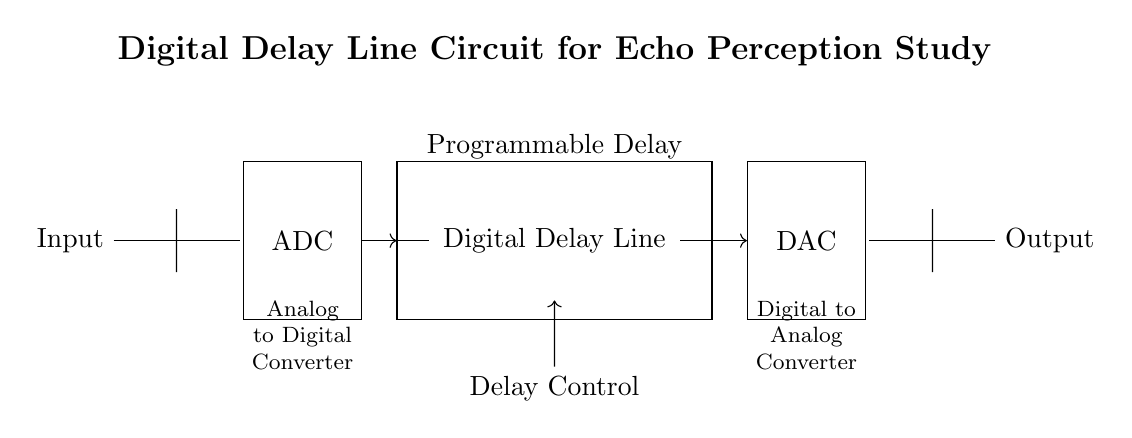What is the first component in the circuit? The first component in the circuit is the Input, which can be seen on the left side. It represents the starting point for signal processing in the circuit.
Answer: Input What is the function of the ADC in this circuit? The ADC (Analog to Digital Converter) converts the incoming analog signal into a digital format, allowing it to be processed by the digital components of the circuit. This is crucial for any digital processing that follows.
Answer: Converts signal What type of circuit is this? This circuit is a Digital Delay Line Circuit, designed for echo perception studies, as indicated in the title of the diagram. It processes audio signals digitally with echo effects.
Answer: Digital Delay Line How many main processing components are in the circuit? The circuit features three main processing components: the ADC, Digital Delay Line, and DAC. These components work together to convert, delay, and convert again the signals as required for the study.
Answer: Three Describe the role of the Delay Control in this circuit. The Delay Control allows the user to program how long the signal delay should be within the Digital Delay Line. This flexibility is necessary to study how different delay times affect echo perception and spatial hearing performance.
Answer: Programmable delay What does DAC stand for in this circuit? DAC stands for Digital to Analog Converter, which converts the processed digital signal back into an analog signal for output. This component is essential for sending the final audio signal to speakers or other analog devices.
Answer: Digital to Analog Converter What is the primary study focus of this circuit? The primary focus of this circuit is to study echo perception and spatial hearing. It is designed to analyze how humans perceive echoes and spatial dimensions in audio signals through programmed delays.
Answer: Echo perception 